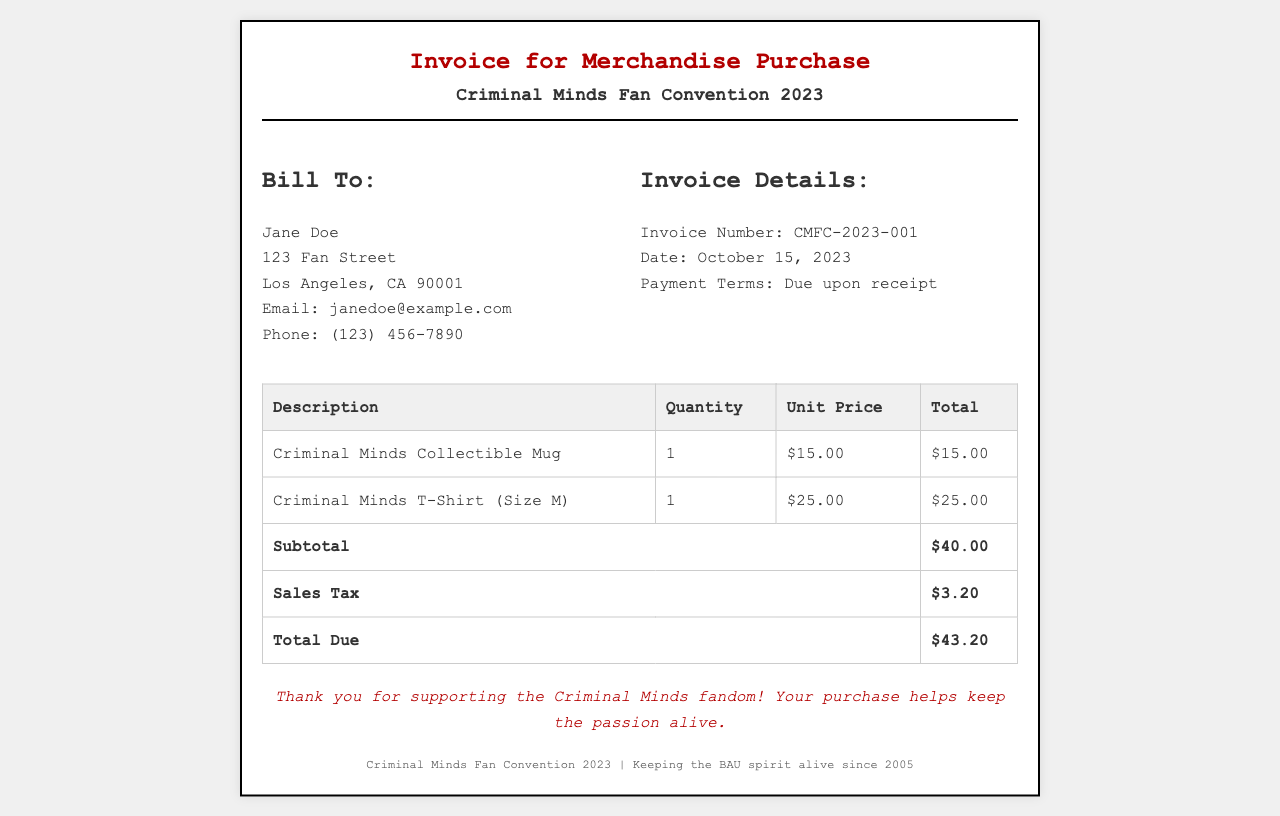What is the invoice number? The invoice number is provided in the invoice details section, which is CMFC-2023-001.
Answer: CMFC-2023-001 Who is billed for the merchandise? The billing information section includes the name of the customer being billed, which is Jane Doe.
Answer: Jane Doe What is the date of the invoice? The date of the invoice is listed in the invoice details section, which is October 15, 2023.
Answer: October 15, 2023 How much is the sales tax? The sales tax amount is stated in the invoice table as $3.20.
Answer: $3.20 What is the total amount due? The total amount due is summarized at the end of the invoice table, which is $43.20.
Answer: $43.20 What item is listed first in the invoice? The first item in the invoice table is the Criminal Minds Collectible Mug.
Answer: Criminal Minds Collectible Mug What is the quantity of T-shirts purchased? The quantity of T-shirts purchased is noted in the invoice table as 1.
Answer: 1 What are the payment terms stated in the invoice? The payment terms are included in the invoice details, which are due upon receipt.
Answer: Due upon receipt What style of T-shirt was purchased? The style of the T-shirt purchased is mentioned in the description, which is Size M.
Answer: Size M 